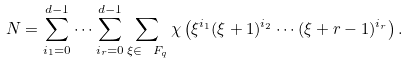Convert formula to latex. <formula><loc_0><loc_0><loc_500><loc_500>N = \sum _ { i _ { 1 } = 0 } ^ { d - 1 } \cdots \sum _ { i _ { r } = 0 } ^ { d - 1 } \sum _ { \xi \in \ F _ { q } } \chi \left ( \xi ^ { i _ { 1 } } ( \xi + 1 ) ^ { i _ { 2 } } \cdots ( \xi + r - 1 ) ^ { i _ { r } } \right ) .</formula> 